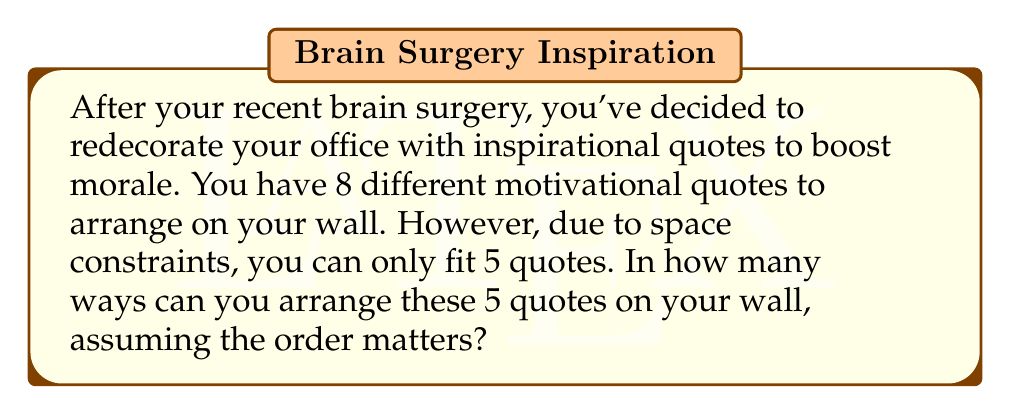Could you help me with this problem? Let's approach this step-by-step:

1) This is a permutation problem. We are selecting 5 quotes out of 8 and arranging them in a specific order.

2) The formula for permutations is:

   $$P(n,r) = \frac{n!}{(n-r)!}$$

   Where $n$ is the total number of items to choose from, and $r$ is the number of items being arranged.

3) In this case, $n = 8$ (total quotes) and $r = 5$ (quotes to be arranged).

4) Plugging these values into our formula:

   $$P(8,5) = \frac{8!}{(8-5)!} = \frac{8!}{3!}$$

5) Let's expand this:
   
   $$\frac{8 * 7 * 6 * 5 * 4 * 3!}{3!}$$

6) The $3!$ cancels out in the numerator and denominator:

   $$8 * 7 * 6 * 5 * 4 = 6720$$

Therefore, there are 6720 ways to arrange 5 quotes out of 8 on your office wall.
Answer: 6720 